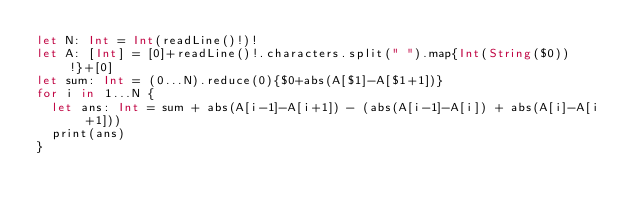<code> <loc_0><loc_0><loc_500><loc_500><_Swift_>let N: Int = Int(readLine()!)!
let A: [Int] = [0]+readLine()!.characters.split(" ").map{Int(String($0))!}+[0]
let sum: Int = (0...N).reduce(0){$0+abs(A[$1]-A[$1+1])}
for i in 1...N {
  let ans: Int = sum + abs(A[i-1]-A[i+1]) - (abs(A[i-1]-A[i]) + abs(A[i]-A[i+1]))
  print(ans)
}</code> 